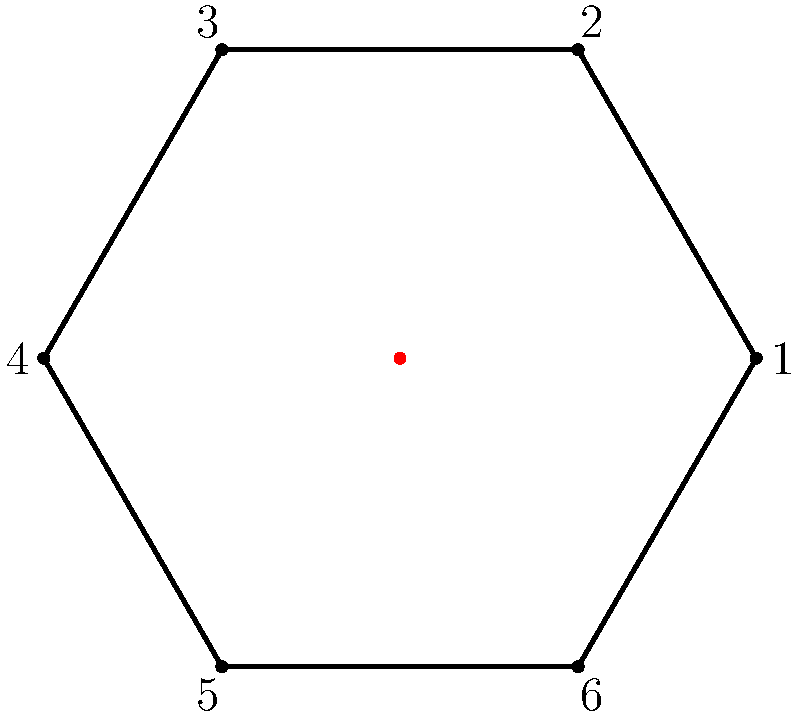Consider the dihedral group $D_6$ represented by symmetries of a regular hexagon. Which elements of $D_6$ correspond to the center of the group? Use the diagram to support your reasoning. To identify the center of the dihedral group $D_6$, we need to follow these steps:

1) Recall that the center of a group consists of elements that commute with all other elements of the group.

2) $D_6$ has 12 elements: 6 rotations (including the identity) and 6 reflections.

3) Consider the rotations:
   - The identity element (rotation by 0°) commutes with all elements.
   - Rotation by 180° (3 vertices) also commutes with all elements, as it's equivalent to two consecutive reflections across any axis.

4) Consider the reflections:
   - No reflection commutes with all other elements. Each reflection fails to commute with rotations that aren't multiples of 180°.

5) Verify using the diagram:
   - The identity rotation leaves all vertices in place.
   - Rotation by 180° maps: 1↔4, 2↔5, 3↔6.
   - Both of these operations commute with any reflection or rotation.

6) Therefore, the center of $D_6$ consists of two elements: the identity and the 180° rotation.
Answer: The identity and 180° rotation 